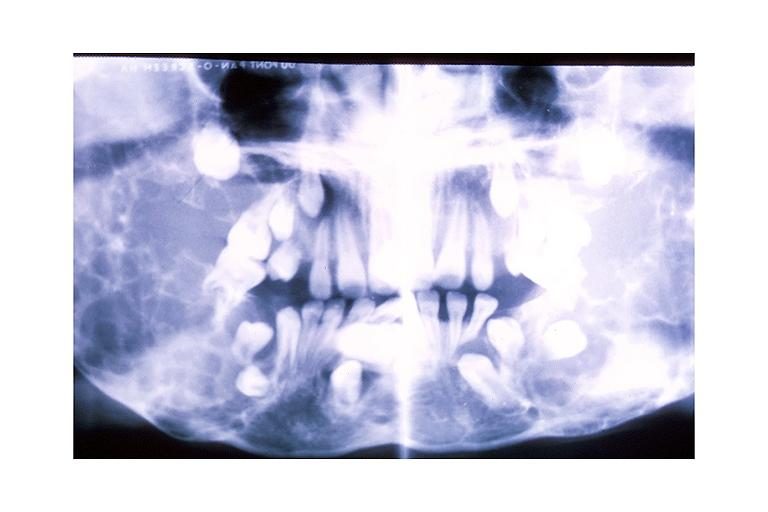does malformed base show cherubism?
Answer the question using a single word or phrase. No 